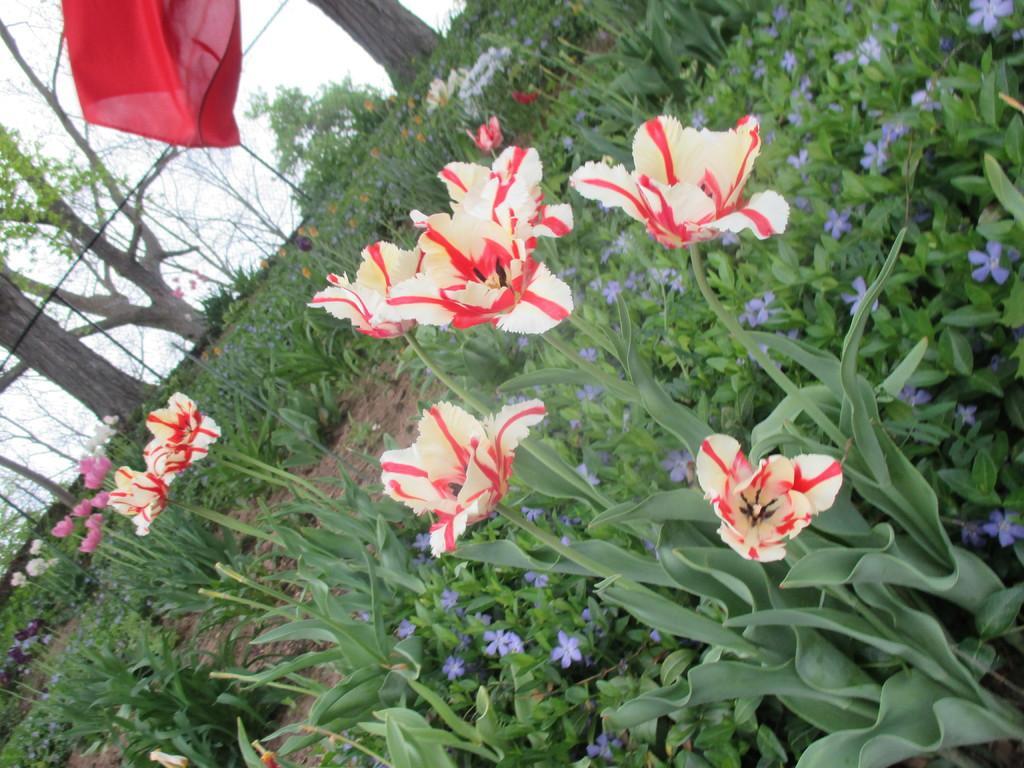How would you summarize this image in a sentence or two? In this image there are flowers and plants. There are trees in the background. And there is a sky at the top. 